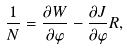Convert formula to latex. <formula><loc_0><loc_0><loc_500><loc_500>\frac { 1 } { N } = \frac { \partial W } { \partial \varphi } - \frac { \partial J } { \partial \varphi } R ,</formula> 